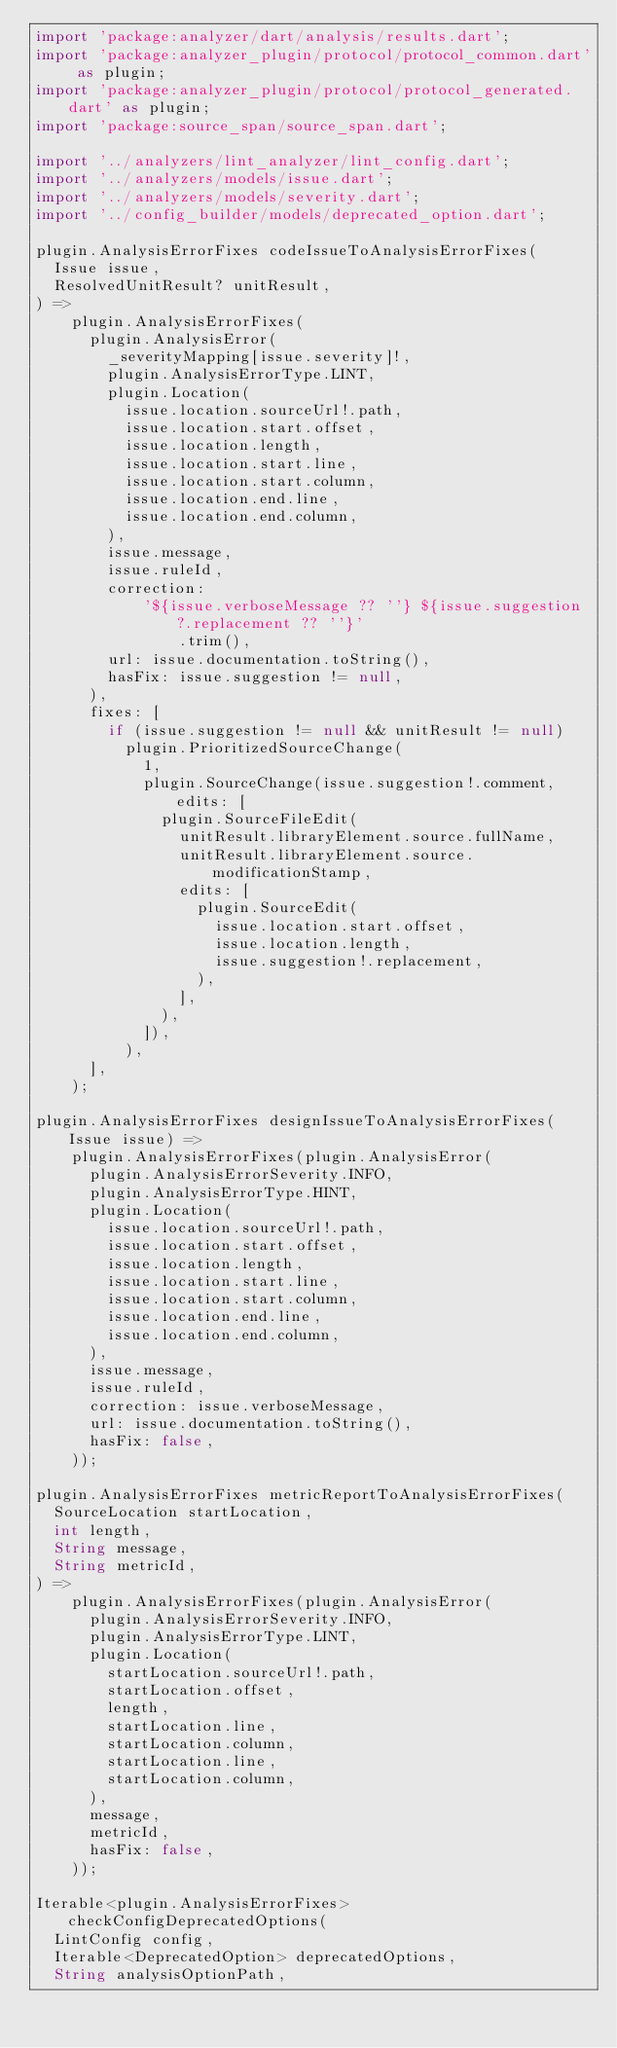Convert code to text. <code><loc_0><loc_0><loc_500><loc_500><_Dart_>import 'package:analyzer/dart/analysis/results.dart';
import 'package:analyzer_plugin/protocol/protocol_common.dart' as plugin;
import 'package:analyzer_plugin/protocol/protocol_generated.dart' as plugin;
import 'package:source_span/source_span.dart';

import '../analyzers/lint_analyzer/lint_config.dart';
import '../analyzers/models/issue.dart';
import '../analyzers/models/severity.dart';
import '../config_builder/models/deprecated_option.dart';

plugin.AnalysisErrorFixes codeIssueToAnalysisErrorFixes(
  Issue issue,
  ResolvedUnitResult? unitResult,
) =>
    plugin.AnalysisErrorFixes(
      plugin.AnalysisError(
        _severityMapping[issue.severity]!,
        plugin.AnalysisErrorType.LINT,
        plugin.Location(
          issue.location.sourceUrl!.path,
          issue.location.start.offset,
          issue.location.length,
          issue.location.start.line,
          issue.location.start.column,
          issue.location.end.line,
          issue.location.end.column,
        ),
        issue.message,
        issue.ruleId,
        correction:
            '${issue.verboseMessage ?? ''} ${issue.suggestion?.replacement ?? ''}'
                .trim(),
        url: issue.documentation.toString(),
        hasFix: issue.suggestion != null,
      ),
      fixes: [
        if (issue.suggestion != null && unitResult != null)
          plugin.PrioritizedSourceChange(
            1,
            plugin.SourceChange(issue.suggestion!.comment, edits: [
              plugin.SourceFileEdit(
                unitResult.libraryElement.source.fullName,
                unitResult.libraryElement.source.modificationStamp,
                edits: [
                  plugin.SourceEdit(
                    issue.location.start.offset,
                    issue.location.length,
                    issue.suggestion!.replacement,
                  ),
                ],
              ),
            ]),
          ),
      ],
    );

plugin.AnalysisErrorFixes designIssueToAnalysisErrorFixes(Issue issue) =>
    plugin.AnalysisErrorFixes(plugin.AnalysisError(
      plugin.AnalysisErrorSeverity.INFO,
      plugin.AnalysisErrorType.HINT,
      plugin.Location(
        issue.location.sourceUrl!.path,
        issue.location.start.offset,
        issue.location.length,
        issue.location.start.line,
        issue.location.start.column,
        issue.location.end.line,
        issue.location.end.column,
      ),
      issue.message,
      issue.ruleId,
      correction: issue.verboseMessage,
      url: issue.documentation.toString(),
      hasFix: false,
    ));

plugin.AnalysisErrorFixes metricReportToAnalysisErrorFixes(
  SourceLocation startLocation,
  int length,
  String message,
  String metricId,
) =>
    plugin.AnalysisErrorFixes(plugin.AnalysisError(
      plugin.AnalysisErrorSeverity.INFO,
      plugin.AnalysisErrorType.LINT,
      plugin.Location(
        startLocation.sourceUrl!.path,
        startLocation.offset,
        length,
        startLocation.line,
        startLocation.column,
        startLocation.line,
        startLocation.column,
      ),
      message,
      metricId,
      hasFix: false,
    ));

Iterable<plugin.AnalysisErrorFixes> checkConfigDeprecatedOptions(
  LintConfig config,
  Iterable<DeprecatedOption> deprecatedOptions,
  String analysisOptionPath,</code> 